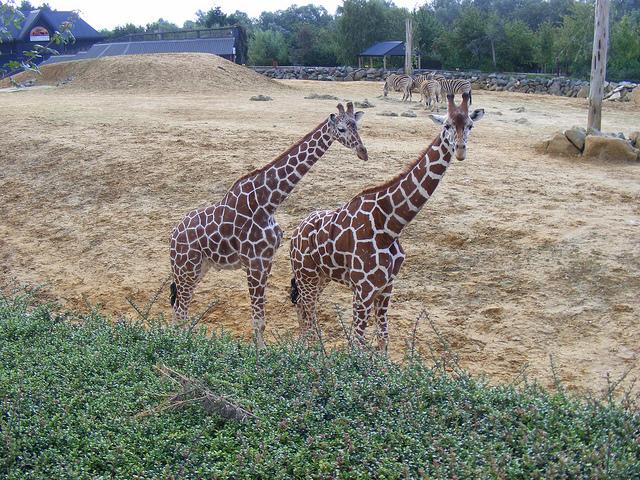Are they in the wild?
Quick response, please. No. How many giraffe in the photo?
Short answer required. 2. Are these reticulated giraffe?
Write a very short answer. Yes. 